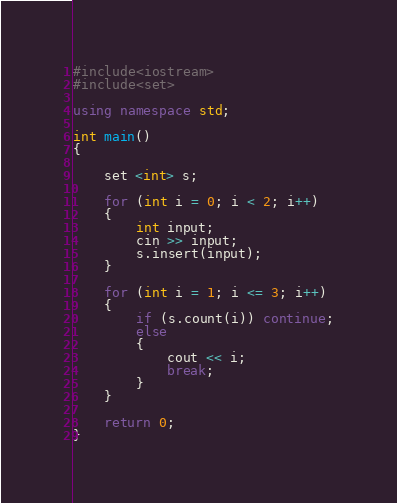Convert code to text. <code><loc_0><loc_0><loc_500><loc_500><_C++_>#include<iostream>
#include<set>

using namespace std;

int main()
{
	
	set <int> s;

	for (int i = 0; i < 2; i++)
	{
		int input;
		cin >> input;
		s.insert(input);
	}

	for (int i = 1; i <= 3; i++)
	{
		if (s.count(i)) continue;
		else
		{
			cout << i;
			break;
		}
	}

	return 0;
}</code> 